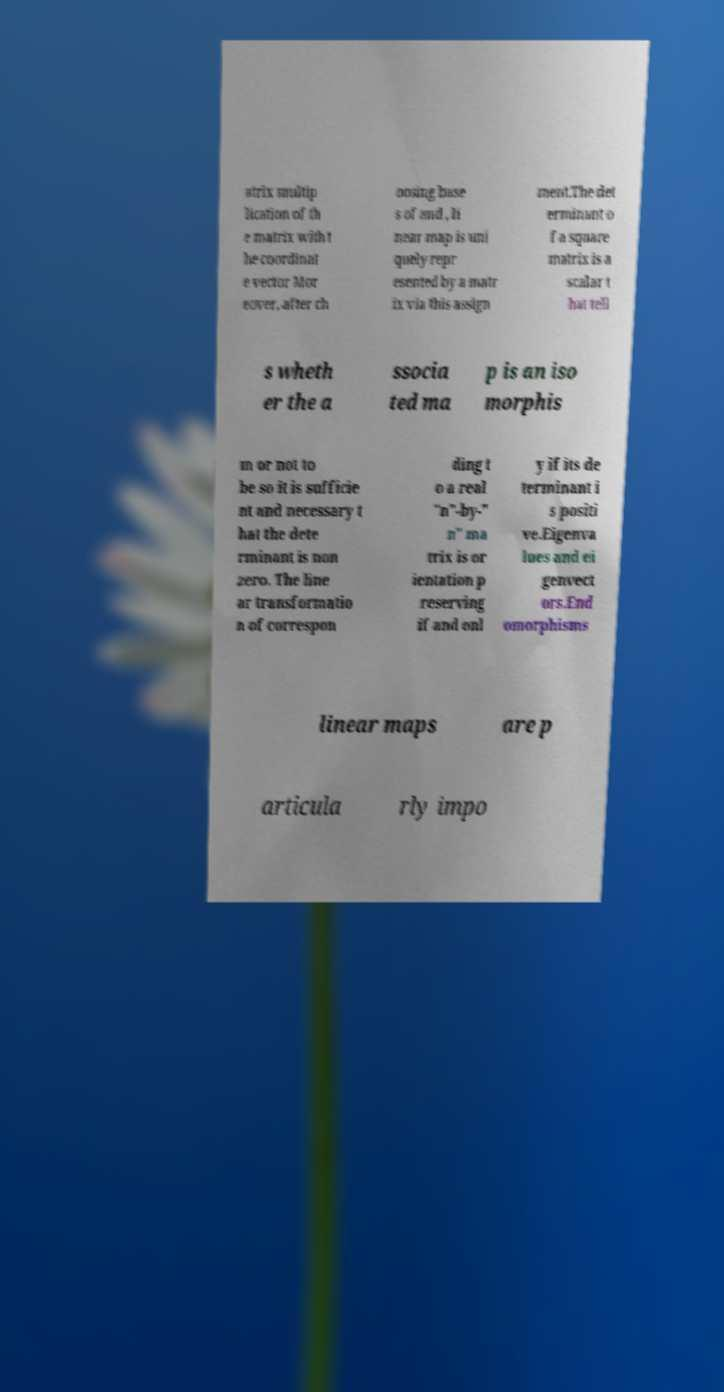Please read and relay the text visible in this image. What does it say? atrix multip lication of th e matrix with t he coordinat e vector Mor eover, after ch oosing base s of and , li near map is uni quely repr esented by a matr ix via this assign ment.The det erminant o f a square matrix is a scalar t hat tell s wheth er the a ssocia ted ma p is an iso morphis m or not to be so it is sufficie nt and necessary t hat the dete rminant is non zero. The line ar transformatio n of correspon ding t o a real "n"-by-" n" ma trix is or ientation p reserving if and onl y if its de terminant i s positi ve.Eigenva lues and ei genvect ors.End omorphisms linear maps are p articula rly impo 